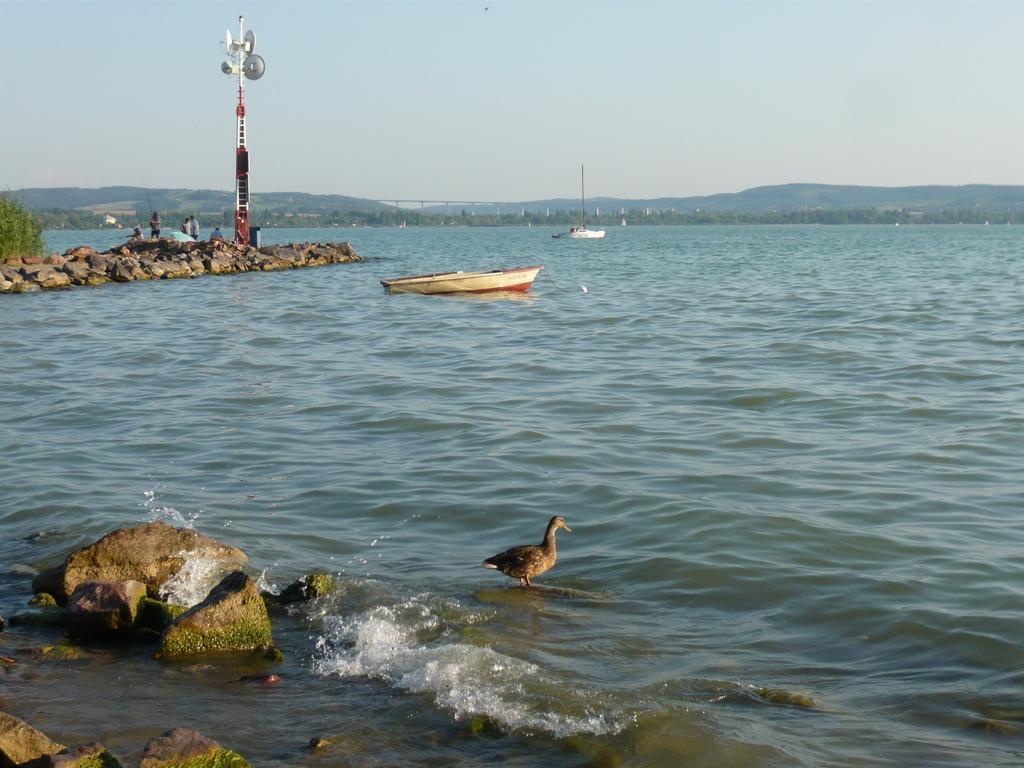Please provide a concise description of this image. In this picture I can see there are few rocks on to left and there is a tower here, there are few people in the boat and there are few other boats sailing on the water and there is a duck here and in the backdrop there is a bridged, there are mountains and the sky is clear. 